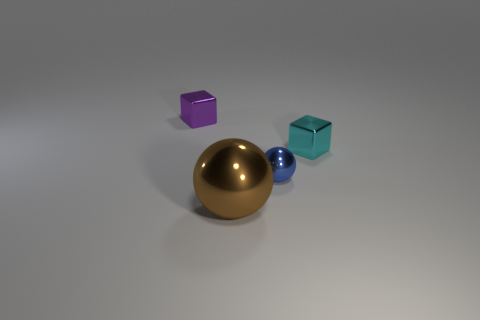Add 3 big brown metallic objects. How many objects exist? 7 Subtract 0 cyan spheres. How many objects are left? 4 Subtract 1 spheres. How many spheres are left? 1 Subtract all brown cubes. Subtract all cyan balls. How many cubes are left? 2 Subtract all cyan spheres. How many purple cubes are left? 1 Subtract all cyan rubber balls. Subtract all purple cubes. How many objects are left? 3 Add 4 small metal things. How many small metal things are left? 7 Add 3 tiny cyan metal objects. How many tiny cyan metal objects exist? 4 Subtract all blue balls. How many balls are left? 1 